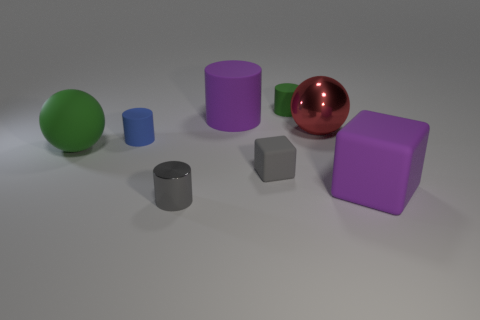Are the gray cube and the purple thing behind the red shiny object made of the same material?
Offer a very short reply. Yes. Is the number of small cyan balls greater than the number of small blue matte objects?
Offer a very short reply. No. How many cubes are tiny blue matte objects or red metallic things?
Keep it short and to the point. 0. The big cylinder has what color?
Your response must be concise. Purple. Does the cube that is on the left side of the big metallic ball have the same size as the green matte thing on the left side of the small gray metallic object?
Your answer should be very brief. No. Are there fewer small gray metallic things than red matte objects?
Keep it short and to the point. No. How many balls are on the left side of the gray shiny cylinder?
Offer a very short reply. 1. What material is the green ball?
Provide a succinct answer. Rubber. Does the small metal cylinder have the same color as the tiny matte cube?
Provide a succinct answer. Yes. Are there fewer tiny gray shiny cylinders that are in front of the big purple matte cylinder than matte objects?
Provide a succinct answer. Yes. 